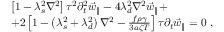<formula> <loc_0><loc_0><loc_500><loc_500>\begin{array} { r l } & { \left [ 1 - \lambda _ { s } ^ { 2 } \nabla ^ { 2 } \right ] \tau ^ { 2 } \partial _ { t } ^ { 2 } \vec { w } _ { \| } - 4 \lambda _ { d } ^ { 2 } \nabla ^ { 2 } \vec { w } _ { \| } + } \\ & { + 2 \left [ 1 - \left ( \lambda _ { s } ^ { 2 } + \lambda _ { d } ^ { 2 } \right ) \nabla ^ { 2 } - \frac { f \rho \gamma } { 3 a \zeta T } \right ] \tau \partial _ { t } \vec { w } _ { \| } = 0 \ , } \end{array}</formula> 